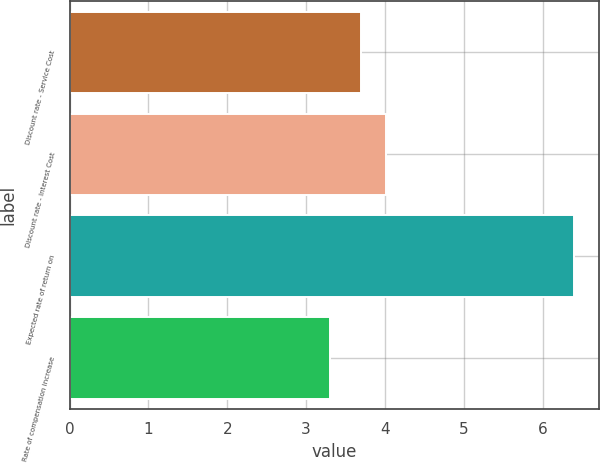<chart> <loc_0><loc_0><loc_500><loc_500><bar_chart><fcel>Discount rate - Service Cost<fcel>Discount rate - Interest Cost<fcel>Expected rate of return on<fcel>Rate of compensation increase<nl><fcel>3.7<fcel>4.01<fcel>6.4<fcel>3.3<nl></chart> 